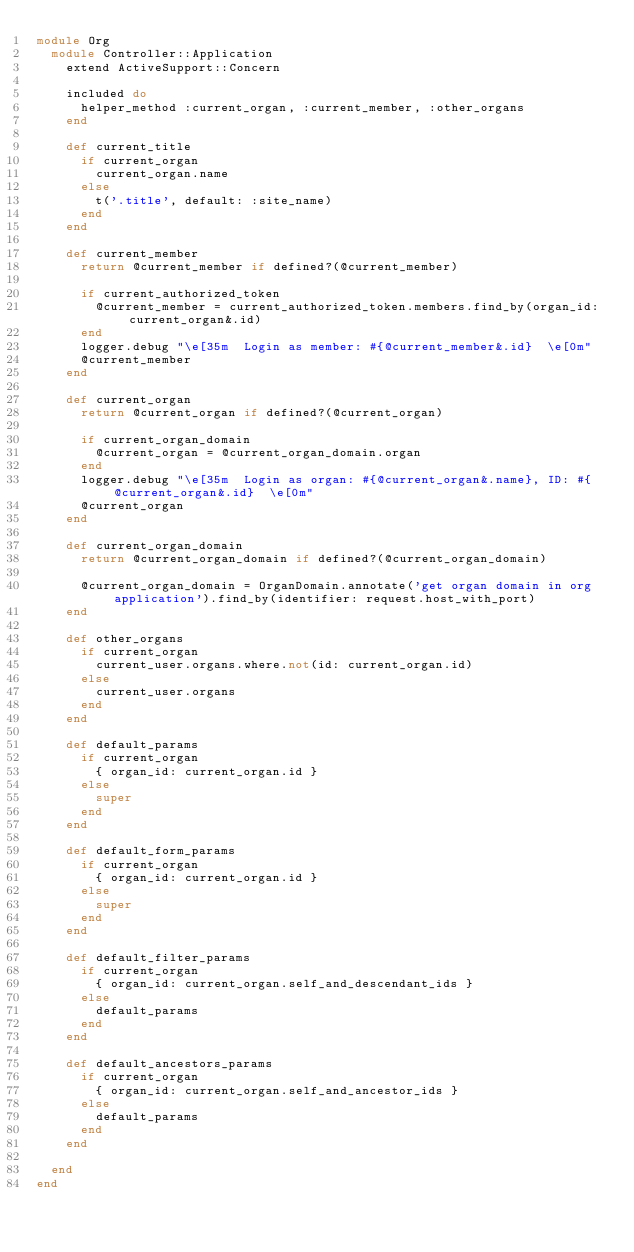<code> <loc_0><loc_0><loc_500><loc_500><_Ruby_>module Org
  module Controller::Application
    extend ActiveSupport::Concern

    included do
      helper_method :current_organ, :current_member, :other_organs
    end

    def current_title
      if current_organ
        current_organ.name
      else
        t('.title', default: :site_name)
      end
    end

    def current_member
      return @current_member if defined?(@current_member)

      if current_authorized_token
        @current_member = current_authorized_token.members.find_by(organ_id: current_organ&.id)
      end
      logger.debug "\e[35m  Login as member: #{@current_member&.id}  \e[0m"
      @current_member
    end

    def current_organ
      return @current_organ if defined?(@current_organ)

      if current_organ_domain
        @current_organ = @current_organ_domain.organ
      end
      logger.debug "\e[35m  Login as organ: #{@current_organ&.name}, ID: #{@current_organ&.id}  \e[0m"
      @current_organ
    end

    def current_organ_domain
      return @current_organ_domain if defined?(@current_organ_domain)

      @current_organ_domain = OrganDomain.annotate('get organ domain in org application').find_by(identifier: request.host_with_port)
    end

    def other_organs
      if current_organ
        current_user.organs.where.not(id: current_organ.id)
      else
        current_user.organs
      end
    end

    def default_params
      if current_organ
        { organ_id: current_organ.id }
      else
        super
      end
    end

    def default_form_params
      if current_organ
        { organ_id: current_organ.id }
      else
        super
      end
    end

    def default_filter_params
      if current_organ
        { organ_id: current_organ.self_and_descendant_ids }
      else
        default_params
      end
    end

    def default_ancestors_params
      if current_organ
        { organ_id: current_organ.self_and_ancestor_ids }
      else
        default_params
      end
    end

  end
end
</code> 